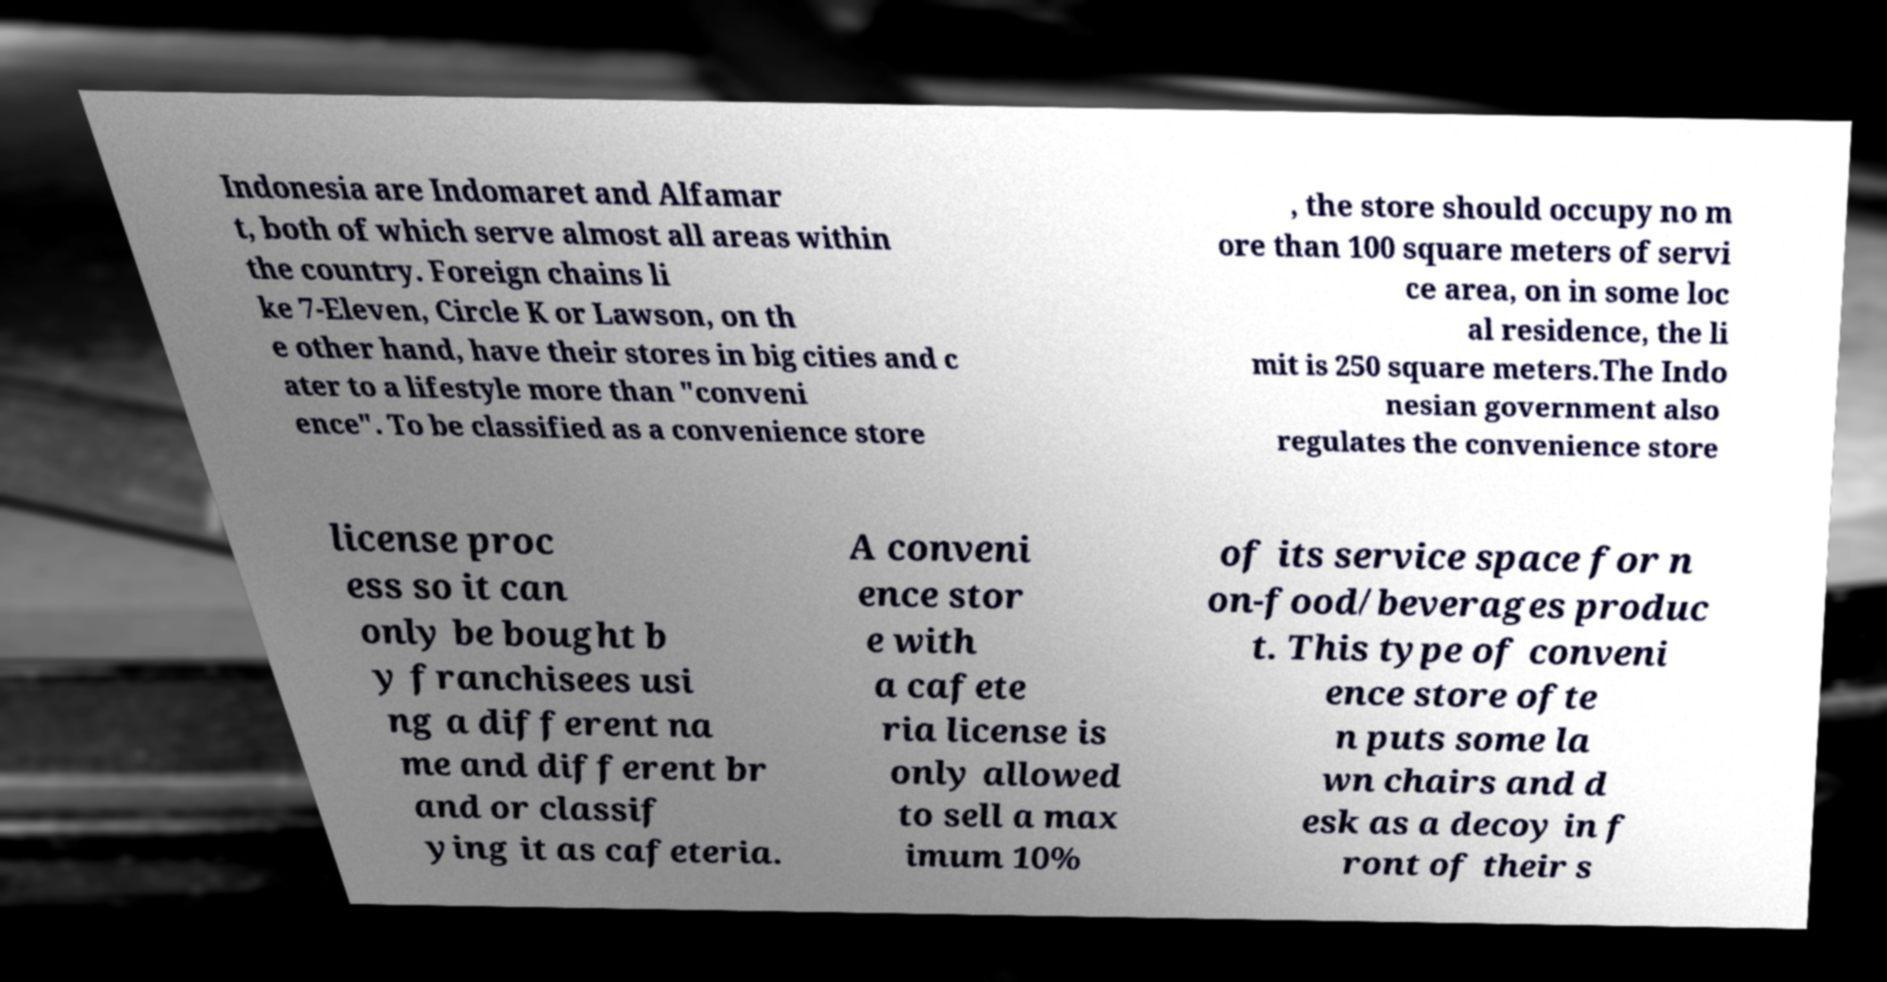Could you assist in decoding the text presented in this image and type it out clearly? Indonesia are Indomaret and Alfamar t, both of which serve almost all areas within the country. Foreign chains li ke 7-Eleven, Circle K or Lawson, on th e other hand, have their stores in big cities and c ater to a lifestyle more than "conveni ence". To be classified as a convenience store , the store should occupy no m ore than 100 square meters of servi ce area, on in some loc al residence, the li mit is 250 square meters.The Indo nesian government also regulates the convenience store license proc ess so it can only be bought b y franchisees usi ng a different na me and different br and or classif ying it as cafeteria. A conveni ence stor e with a cafete ria license is only allowed to sell a max imum 10% of its service space for n on-food/beverages produc t. This type of conveni ence store ofte n puts some la wn chairs and d esk as a decoy in f ront of their s 